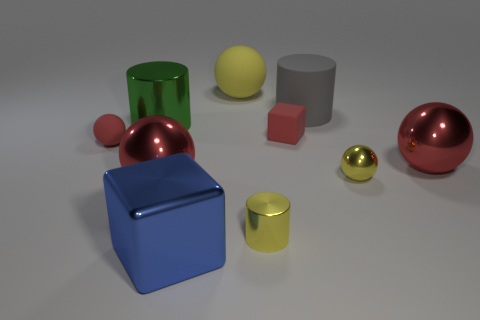How many red spheres must be subtracted to get 1 red spheres? 2 Subtract 1 blocks. How many blocks are left? 1 Subtract all yellow spheres. How many spheres are left? 3 Subtract all rubber balls. How many balls are left? 3 Subtract 0 brown cubes. How many objects are left? 10 Subtract all cubes. How many objects are left? 8 Subtract all blue spheres. Subtract all brown cubes. How many spheres are left? 5 Subtract all red cylinders. How many green spheres are left? 0 Subtract all yellow metal cylinders. Subtract all tiny red rubber cubes. How many objects are left? 8 Add 3 yellow balls. How many yellow balls are left? 5 